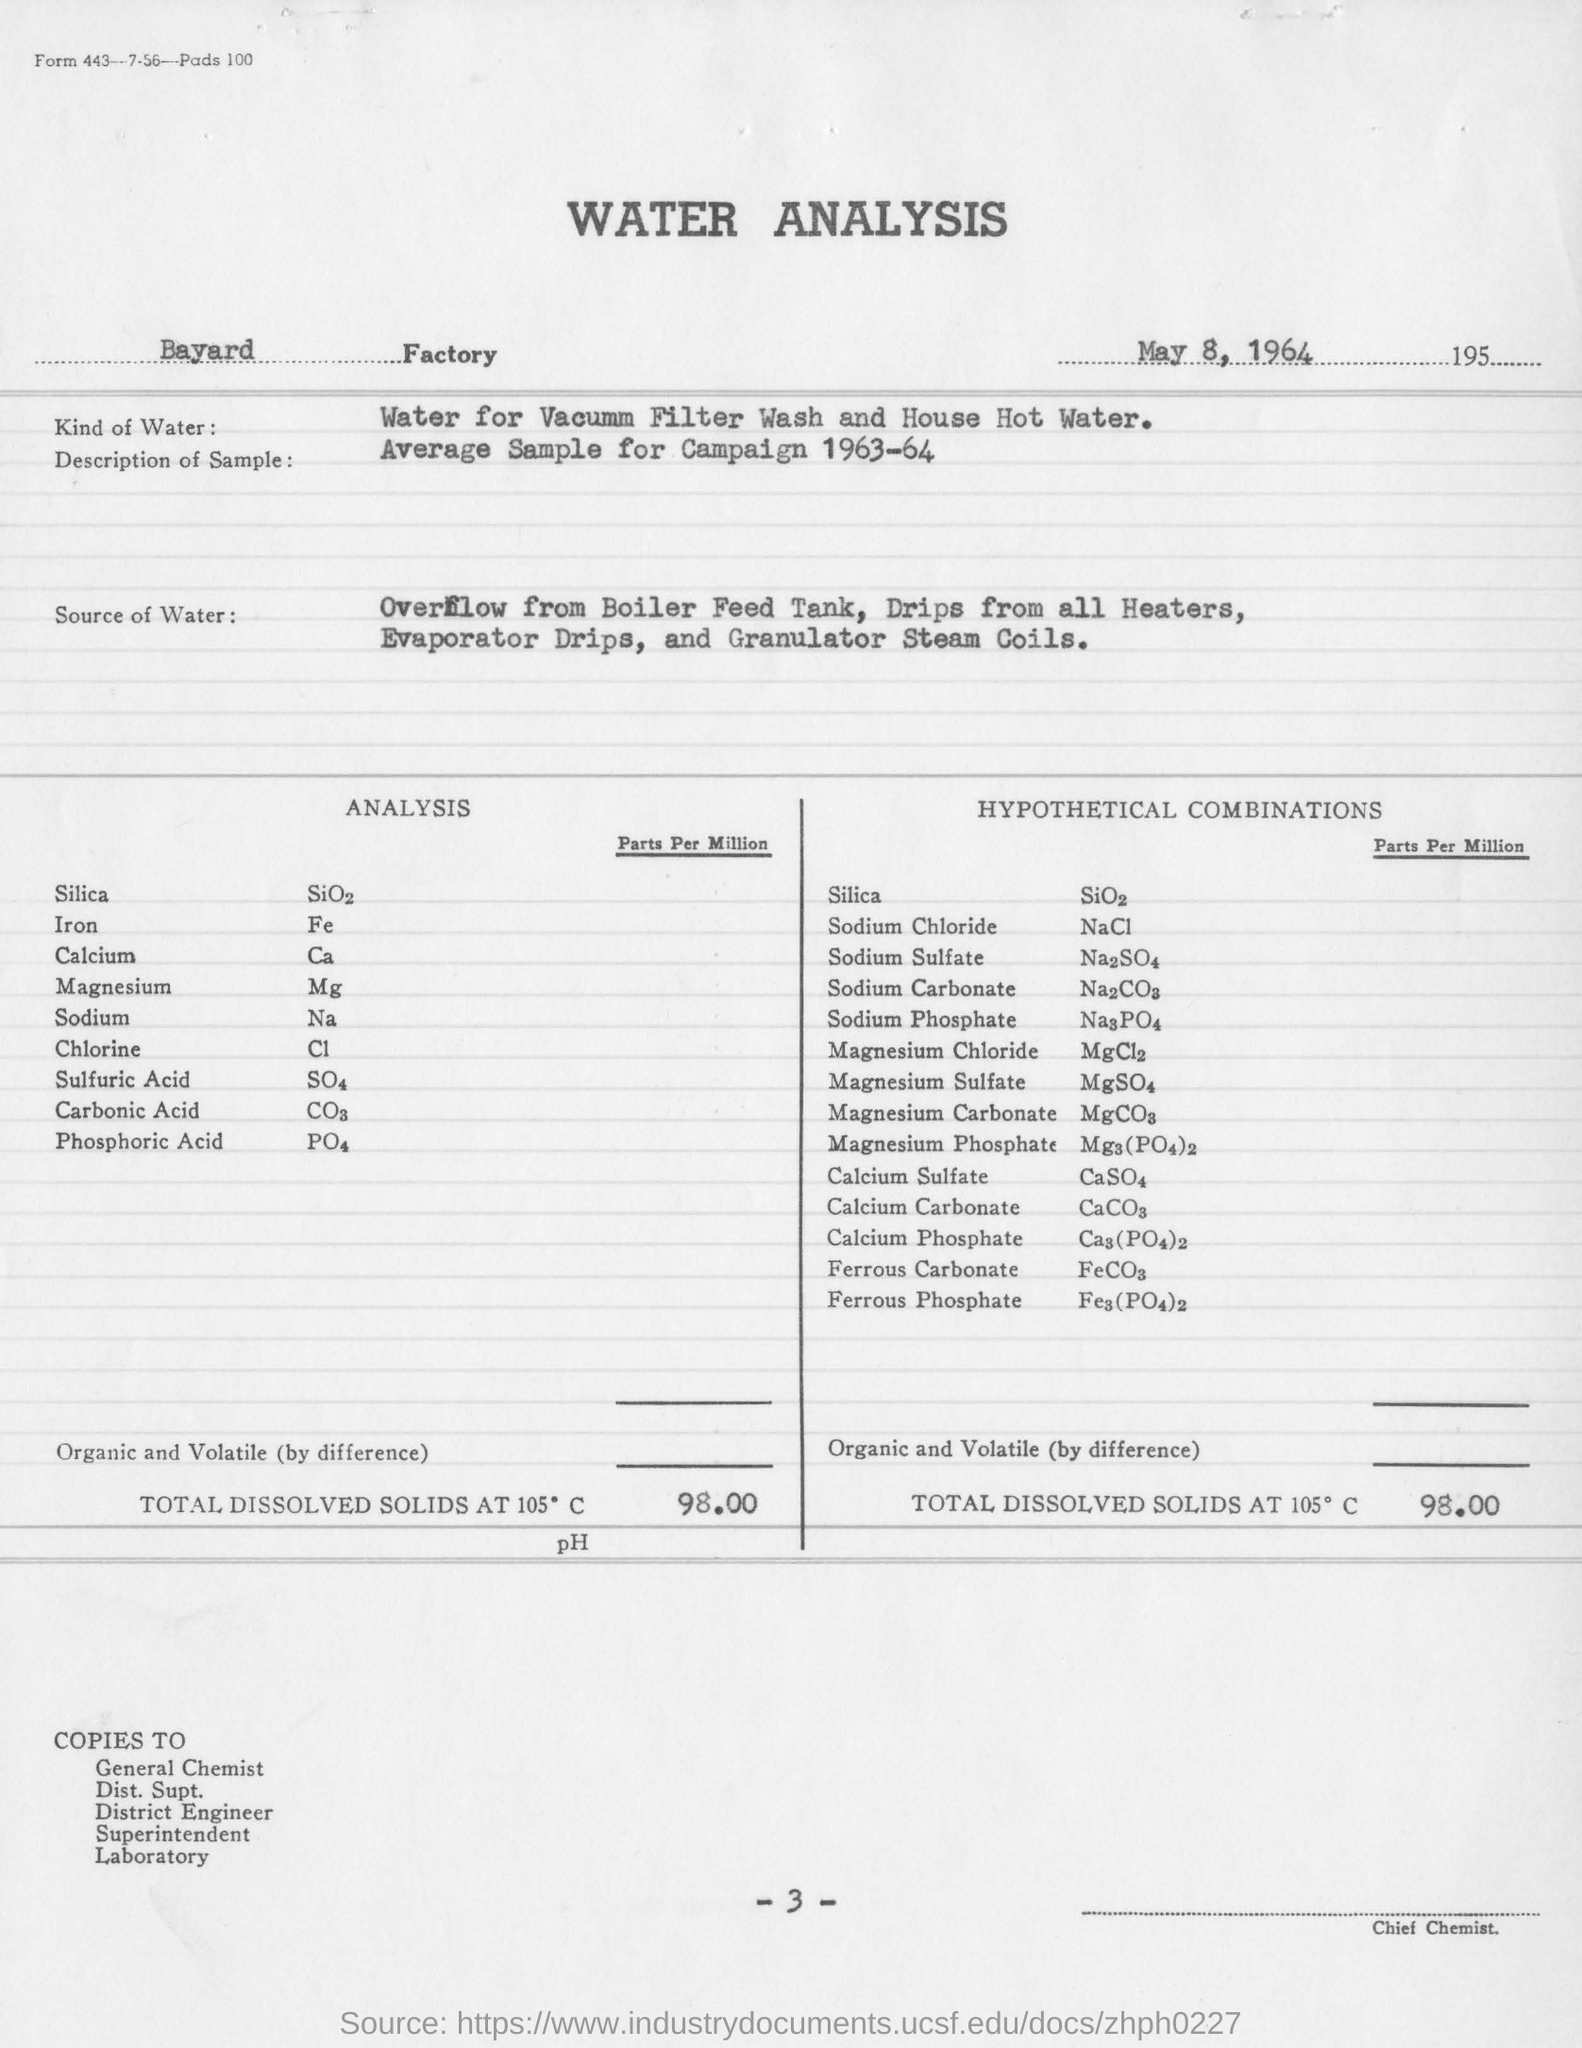What is the date mentioned in this report?
Provide a short and direct response. May 8, 1964. What is factory name printed in this report?
Keep it short and to the point. Bayard. 